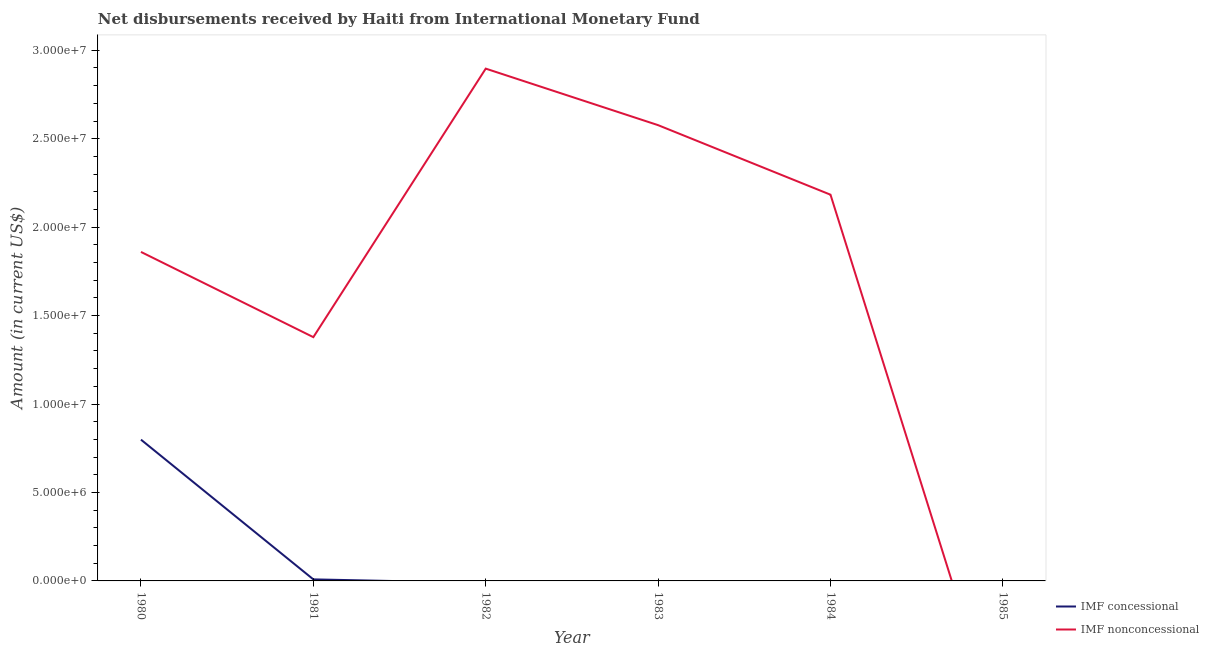Does the line corresponding to net non concessional disbursements from imf intersect with the line corresponding to net concessional disbursements from imf?
Give a very brief answer. Yes. What is the net concessional disbursements from imf in 1981?
Ensure brevity in your answer.  8.70e+04. Across all years, what is the maximum net non concessional disbursements from imf?
Your response must be concise. 2.90e+07. Across all years, what is the minimum net non concessional disbursements from imf?
Offer a terse response. 0. What is the total net non concessional disbursements from imf in the graph?
Give a very brief answer. 1.09e+08. What is the difference between the net non concessional disbursements from imf in 1981 and that in 1984?
Ensure brevity in your answer.  -8.05e+06. What is the difference between the net concessional disbursements from imf in 1983 and the net non concessional disbursements from imf in 1985?
Provide a succinct answer. 0. What is the average net concessional disbursements from imf per year?
Your answer should be compact. 1.35e+06. In the year 1980, what is the difference between the net concessional disbursements from imf and net non concessional disbursements from imf?
Provide a succinct answer. -1.06e+07. What is the ratio of the net non concessional disbursements from imf in 1980 to that in 1983?
Make the answer very short. 0.72. What is the difference between the highest and the lowest net concessional disbursements from imf?
Ensure brevity in your answer.  7.99e+06. Is the sum of the net non concessional disbursements from imf in 1981 and 1982 greater than the maximum net concessional disbursements from imf across all years?
Your answer should be very brief. Yes. Is the net concessional disbursements from imf strictly less than the net non concessional disbursements from imf over the years?
Give a very brief answer. No. How many years are there in the graph?
Ensure brevity in your answer.  6. What is the difference between two consecutive major ticks on the Y-axis?
Ensure brevity in your answer.  5.00e+06. Are the values on the major ticks of Y-axis written in scientific E-notation?
Your answer should be very brief. Yes. Does the graph contain any zero values?
Offer a very short reply. Yes. Where does the legend appear in the graph?
Your response must be concise. Bottom right. How are the legend labels stacked?
Your answer should be very brief. Vertical. What is the title of the graph?
Keep it short and to the point. Net disbursements received by Haiti from International Monetary Fund. Does "Study and work" appear as one of the legend labels in the graph?
Make the answer very short. No. What is the label or title of the X-axis?
Provide a succinct answer. Year. What is the label or title of the Y-axis?
Make the answer very short. Amount (in current US$). What is the Amount (in current US$) of IMF concessional in 1980?
Give a very brief answer. 7.99e+06. What is the Amount (in current US$) of IMF nonconcessional in 1980?
Offer a very short reply. 1.86e+07. What is the Amount (in current US$) in IMF concessional in 1981?
Make the answer very short. 8.70e+04. What is the Amount (in current US$) of IMF nonconcessional in 1981?
Make the answer very short. 1.38e+07. What is the Amount (in current US$) of IMF concessional in 1982?
Your response must be concise. 0. What is the Amount (in current US$) of IMF nonconcessional in 1982?
Provide a short and direct response. 2.90e+07. What is the Amount (in current US$) of IMF nonconcessional in 1983?
Make the answer very short. 2.58e+07. What is the Amount (in current US$) in IMF nonconcessional in 1984?
Provide a short and direct response. 2.18e+07. Across all years, what is the maximum Amount (in current US$) of IMF concessional?
Ensure brevity in your answer.  7.99e+06. Across all years, what is the maximum Amount (in current US$) of IMF nonconcessional?
Your response must be concise. 2.90e+07. What is the total Amount (in current US$) of IMF concessional in the graph?
Provide a short and direct response. 8.07e+06. What is the total Amount (in current US$) of IMF nonconcessional in the graph?
Keep it short and to the point. 1.09e+08. What is the difference between the Amount (in current US$) of IMF concessional in 1980 and that in 1981?
Offer a terse response. 7.90e+06. What is the difference between the Amount (in current US$) in IMF nonconcessional in 1980 and that in 1981?
Make the answer very short. 4.82e+06. What is the difference between the Amount (in current US$) in IMF nonconcessional in 1980 and that in 1982?
Make the answer very short. -1.04e+07. What is the difference between the Amount (in current US$) in IMF nonconcessional in 1980 and that in 1983?
Ensure brevity in your answer.  -7.17e+06. What is the difference between the Amount (in current US$) of IMF nonconcessional in 1980 and that in 1984?
Offer a terse response. -3.24e+06. What is the difference between the Amount (in current US$) of IMF nonconcessional in 1981 and that in 1982?
Give a very brief answer. -1.52e+07. What is the difference between the Amount (in current US$) in IMF nonconcessional in 1981 and that in 1983?
Your answer should be compact. -1.20e+07. What is the difference between the Amount (in current US$) in IMF nonconcessional in 1981 and that in 1984?
Make the answer very short. -8.05e+06. What is the difference between the Amount (in current US$) in IMF nonconcessional in 1982 and that in 1983?
Keep it short and to the point. 3.20e+06. What is the difference between the Amount (in current US$) of IMF nonconcessional in 1982 and that in 1984?
Provide a succinct answer. 7.13e+06. What is the difference between the Amount (in current US$) of IMF nonconcessional in 1983 and that in 1984?
Offer a very short reply. 3.93e+06. What is the difference between the Amount (in current US$) in IMF concessional in 1980 and the Amount (in current US$) in IMF nonconcessional in 1981?
Make the answer very short. -5.79e+06. What is the difference between the Amount (in current US$) of IMF concessional in 1980 and the Amount (in current US$) of IMF nonconcessional in 1982?
Offer a very short reply. -2.10e+07. What is the difference between the Amount (in current US$) of IMF concessional in 1980 and the Amount (in current US$) of IMF nonconcessional in 1983?
Give a very brief answer. -1.78e+07. What is the difference between the Amount (in current US$) of IMF concessional in 1980 and the Amount (in current US$) of IMF nonconcessional in 1984?
Your response must be concise. -1.38e+07. What is the difference between the Amount (in current US$) in IMF concessional in 1981 and the Amount (in current US$) in IMF nonconcessional in 1982?
Make the answer very short. -2.89e+07. What is the difference between the Amount (in current US$) in IMF concessional in 1981 and the Amount (in current US$) in IMF nonconcessional in 1983?
Your answer should be compact. -2.57e+07. What is the difference between the Amount (in current US$) in IMF concessional in 1981 and the Amount (in current US$) in IMF nonconcessional in 1984?
Your answer should be compact. -2.17e+07. What is the average Amount (in current US$) of IMF concessional per year?
Keep it short and to the point. 1.35e+06. What is the average Amount (in current US$) of IMF nonconcessional per year?
Provide a succinct answer. 1.82e+07. In the year 1980, what is the difference between the Amount (in current US$) of IMF concessional and Amount (in current US$) of IMF nonconcessional?
Keep it short and to the point. -1.06e+07. In the year 1981, what is the difference between the Amount (in current US$) in IMF concessional and Amount (in current US$) in IMF nonconcessional?
Provide a short and direct response. -1.37e+07. What is the ratio of the Amount (in current US$) of IMF concessional in 1980 to that in 1981?
Ensure brevity in your answer.  91.8. What is the ratio of the Amount (in current US$) of IMF nonconcessional in 1980 to that in 1981?
Provide a short and direct response. 1.35. What is the ratio of the Amount (in current US$) in IMF nonconcessional in 1980 to that in 1982?
Offer a terse response. 0.64. What is the ratio of the Amount (in current US$) in IMF nonconcessional in 1980 to that in 1983?
Keep it short and to the point. 0.72. What is the ratio of the Amount (in current US$) of IMF nonconcessional in 1980 to that in 1984?
Your response must be concise. 0.85. What is the ratio of the Amount (in current US$) in IMF nonconcessional in 1981 to that in 1982?
Provide a short and direct response. 0.48. What is the ratio of the Amount (in current US$) of IMF nonconcessional in 1981 to that in 1983?
Provide a succinct answer. 0.53. What is the ratio of the Amount (in current US$) of IMF nonconcessional in 1981 to that in 1984?
Offer a very short reply. 0.63. What is the ratio of the Amount (in current US$) in IMF nonconcessional in 1982 to that in 1983?
Your answer should be compact. 1.12. What is the ratio of the Amount (in current US$) in IMF nonconcessional in 1982 to that in 1984?
Keep it short and to the point. 1.33. What is the ratio of the Amount (in current US$) in IMF nonconcessional in 1983 to that in 1984?
Provide a succinct answer. 1.18. What is the difference between the highest and the second highest Amount (in current US$) of IMF nonconcessional?
Provide a short and direct response. 3.20e+06. What is the difference between the highest and the lowest Amount (in current US$) in IMF concessional?
Ensure brevity in your answer.  7.99e+06. What is the difference between the highest and the lowest Amount (in current US$) in IMF nonconcessional?
Your answer should be very brief. 2.90e+07. 